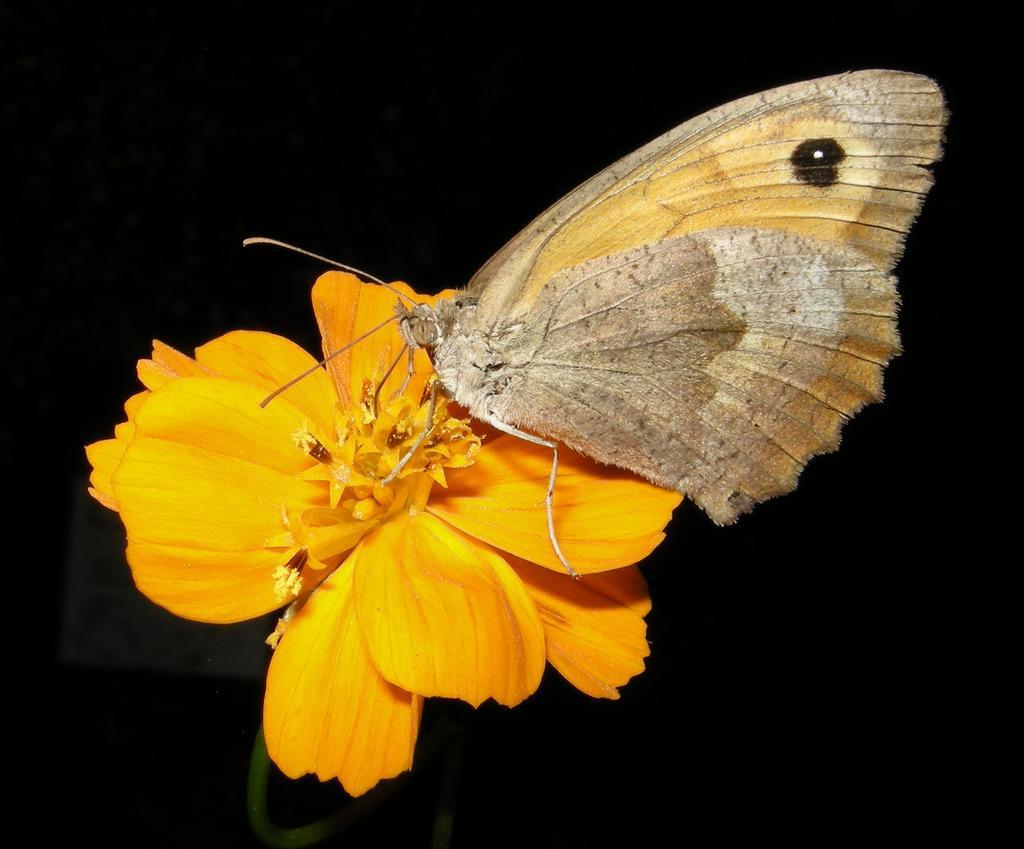Could you give a brief overview of what you see in this image? The picture consists of a flower and a butterfly. The background is dark. 